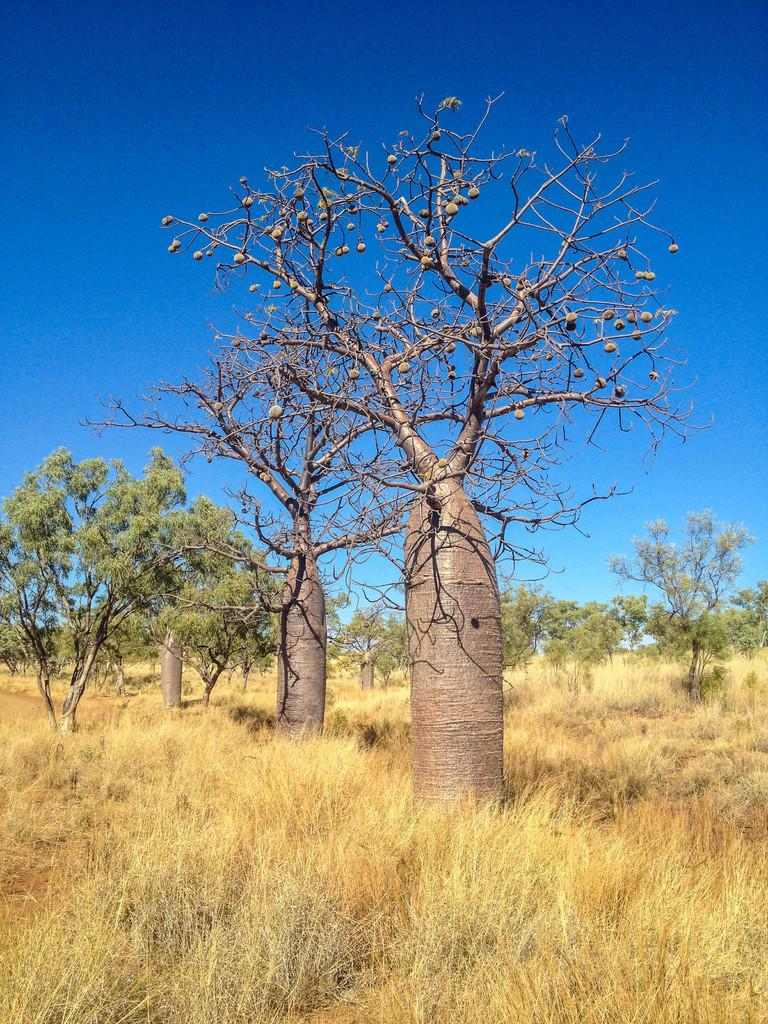What type of vegetation is in the center of the image? There are trees in the center of the image. What type of ground cover is at the bottom of the image? There is grass at the bottom of the image. What can be seen in the background of the image? The sky is visible in the background of the image. What type of dress is hanging on the tree in the image? There is no dress present in the image; it features trees, grass, and the sky. How many hands are visible in the image? There are no hands visible in the image. 